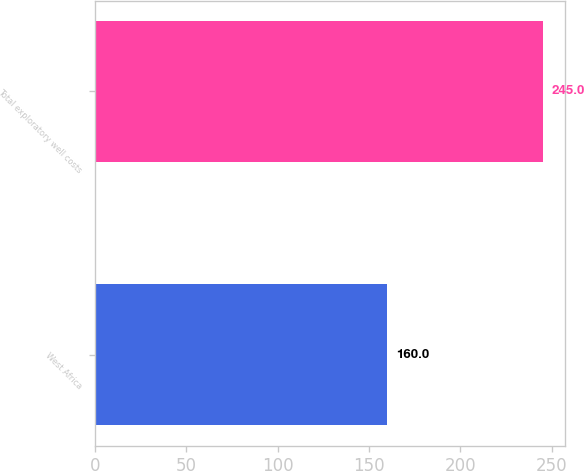Convert chart to OTSL. <chart><loc_0><loc_0><loc_500><loc_500><bar_chart><fcel>West Africa<fcel>Total exploratory well costs<nl><fcel>160<fcel>245<nl></chart> 